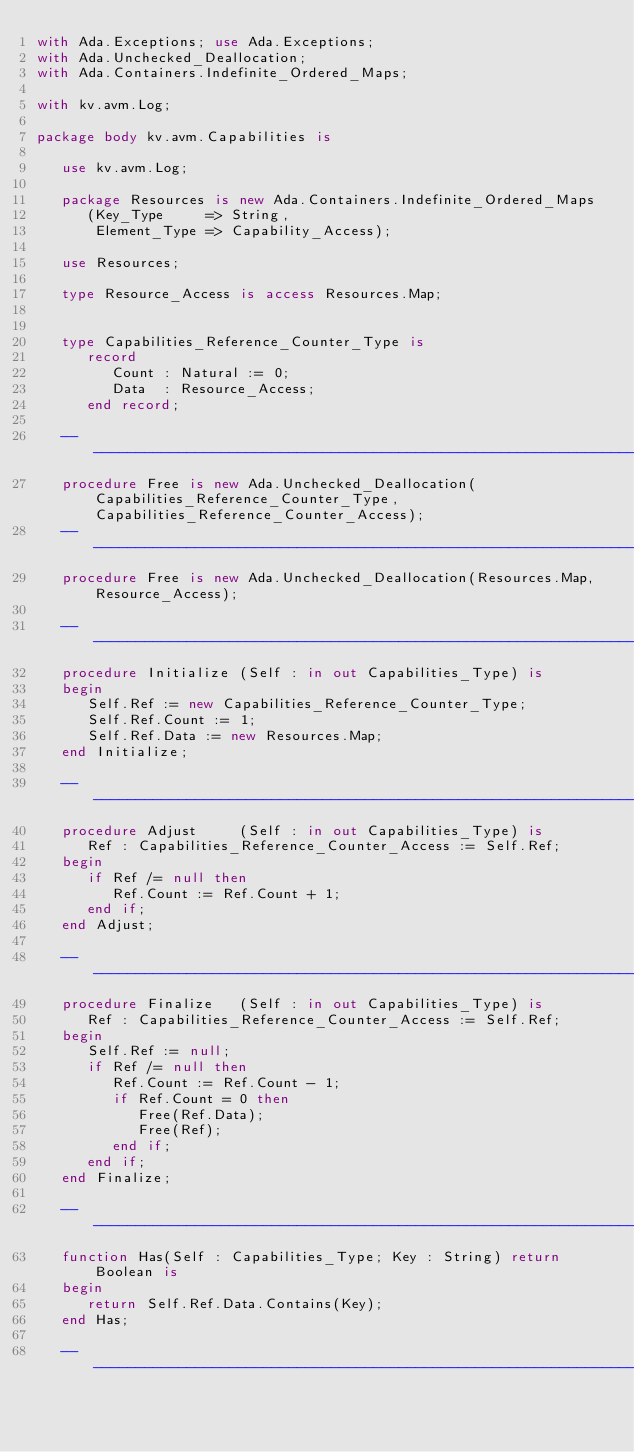<code> <loc_0><loc_0><loc_500><loc_500><_Ada_>with Ada.Exceptions; use Ada.Exceptions;
with Ada.Unchecked_Deallocation;
with Ada.Containers.Indefinite_Ordered_Maps;

with kv.avm.Log;

package body kv.avm.Capabilities is

   use kv.avm.Log;

   package Resources is new Ada.Containers.Indefinite_Ordered_Maps
      (Key_Type     => String,
       Element_Type => Capability_Access);

   use Resources;

   type Resource_Access is access Resources.Map;


   type Capabilities_Reference_Counter_Type is
      record
         Count : Natural := 0;
         Data  : Resource_Access;
      end record;

   -----------------------------------------------------------------------------
   procedure Free is new Ada.Unchecked_Deallocation(Capabilities_Reference_Counter_Type, Capabilities_Reference_Counter_Access);
   -----------------------------------------------------------------------------
   procedure Free is new Ada.Unchecked_Deallocation(Resources.Map, Resource_Access);

   -----------------------------------------------------------------------------
   procedure Initialize (Self : in out Capabilities_Type) is
   begin
      Self.Ref := new Capabilities_Reference_Counter_Type;
      Self.Ref.Count := 1;
      Self.Ref.Data := new Resources.Map;
   end Initialize;

   -----------------------------------------------------------------------------
   procedure Adjust     (Self : in out Capabilities_Type) is
      Ref : Capabilities_Reference_Counter_Access := Self.Ref;
   begin
      if Ref /= null then
         Ref.Count := Ref.Count + 1;
      end if;
   end Adjust;

   -----------------------------------------------------------------------------
   procedure Finalize   (Self : in out Capabilities_Type) is
      Ref : Capabilities_Reference_Counter_Access := Self.Ref;
   begin
      Self.Ref := null;
      if Ref /= null then
         Ref.Count := Ref.Count - 1;
         if Ref.Count = 0 then
            Free(Ref.Data);
            Free(Ref);
         end if;
      end if;
   end Finalize;

   -----------------------------------------------------------------------------
   function Has(Self : Capabilities_Type; Key : String) return Boolean is
   begin
      return Self.Ref.Data.Contains(Key);
   end Has;

   -----------------------------------------------------------------------------</code> 